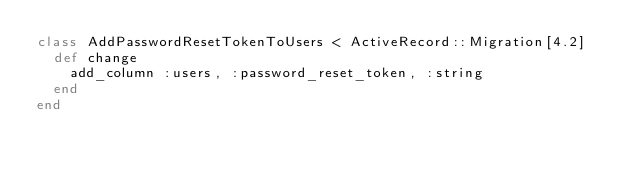Convert code to text. <code><loc_0><loc_0><loc_500><loc_500><_Ruby_>class AddPasswordResetTokenToUsers < ActiveRecord::Migration[4.2]
  def change
    add_column :users, :password_reset_token, :string
  end
end
</code> 